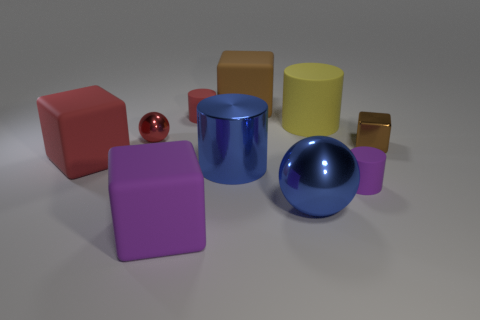How do the sizes of the different objects compare in the image? In the image, the objects vary significantly in size. The large blue sphere and purple cube are the most prominent, followed by the smaller gold cube and the medium-sized yellow cylinder. The red sphere is the smallest object present. Can you tell which object is closest to the front? The red sphere appears to be the closest object to the front, based on its size and the perspective from which the image is taken. 